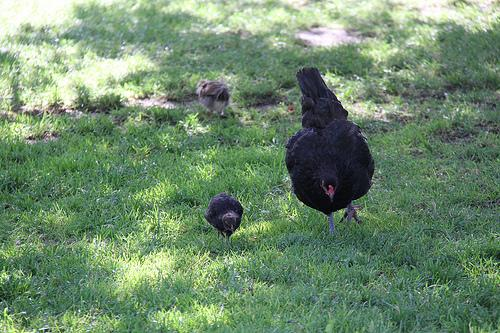Mention the colors and the main subject in the image. Black and red chickens, a gray baby chick, and a green grassy yard. Write a detailed description of the largest animal in the image. A large black chicken with a red crest walks across the grass, displaying its shiny dark gray beak and skinny legs with gray talons. Explain the different components of the image as a list. - Chicken's skinny legs Share a fun fact or observation about one of the subjects in the image. The baby chick has tiny shiny gray talons, perfect for exploring the grassy yard with its family. What are the three main subjects in the image? A family of black chickens, baby chicks, and a grassy yard with dirt patches. Briefly mention the key elements of the image. Three black chickens, baby chicks, grassy yard, and dirt patches in the grass. Narrate a short story about the picture. In a grassy yard, a family of chickens explored their surroundings, with a baby chick following its mother as they searched for food in the grass. Describe the scene in the image using a poetic style. In the sunlit meadow's embrace, a family of black chickens with red accents gently roams, a baby chick tenderly following, exploring life's green tapestry. Explain the relationship between the subjects in the image. In a grassy yard, a family of black chickens, including baby chicks, walk together, interacting with their surroundings and each other. Compose a haiku inspired by the image. Grass whispers softly 